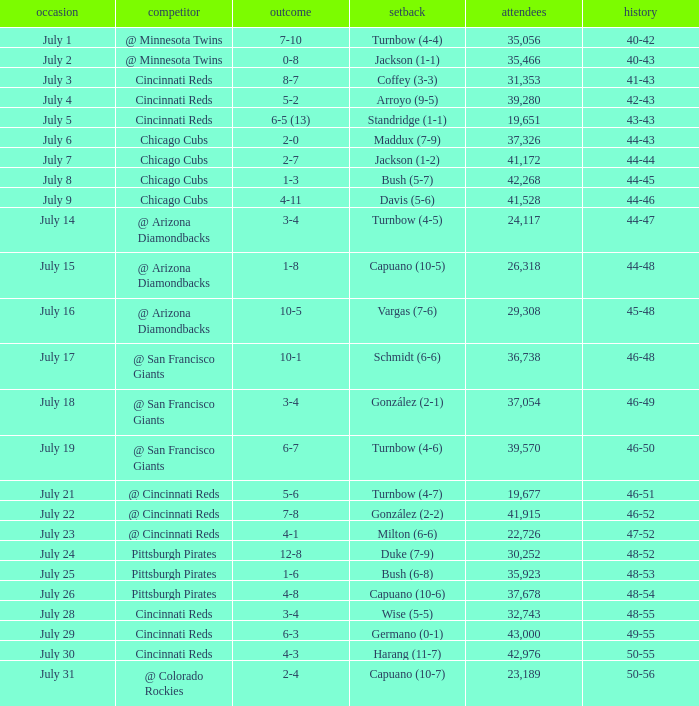What was the record at the game that had a score of 7-10? 40-42. 